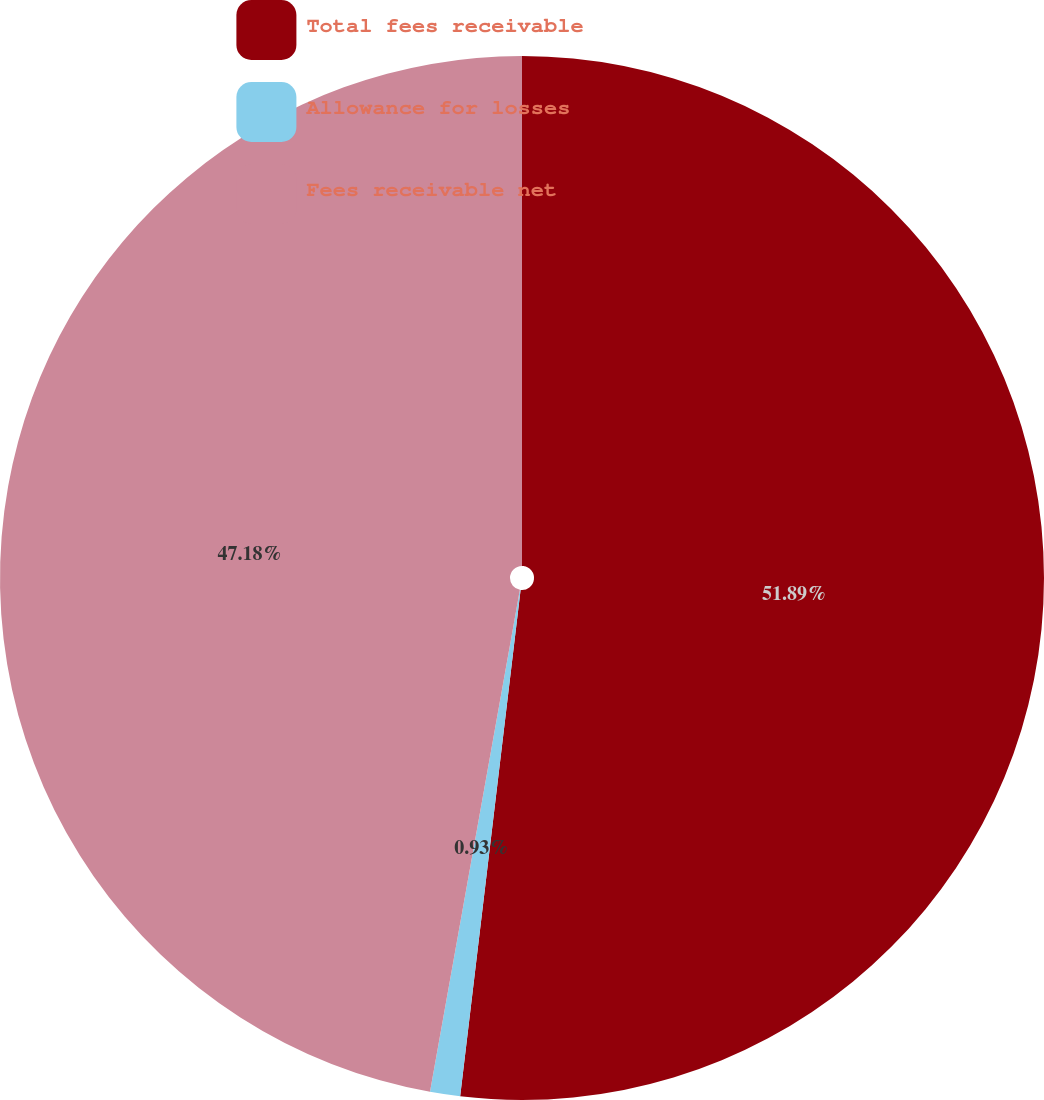<chart> <loc_0><loc_0><loc_500><loc_500><pie_chart><fcel>Total fees receivable<fcel>Allowance for losses<fcel>Fees receivable net<nl><fcel>51.89%<fcel>0.93%<fcel>47.18%<nl></chart> 